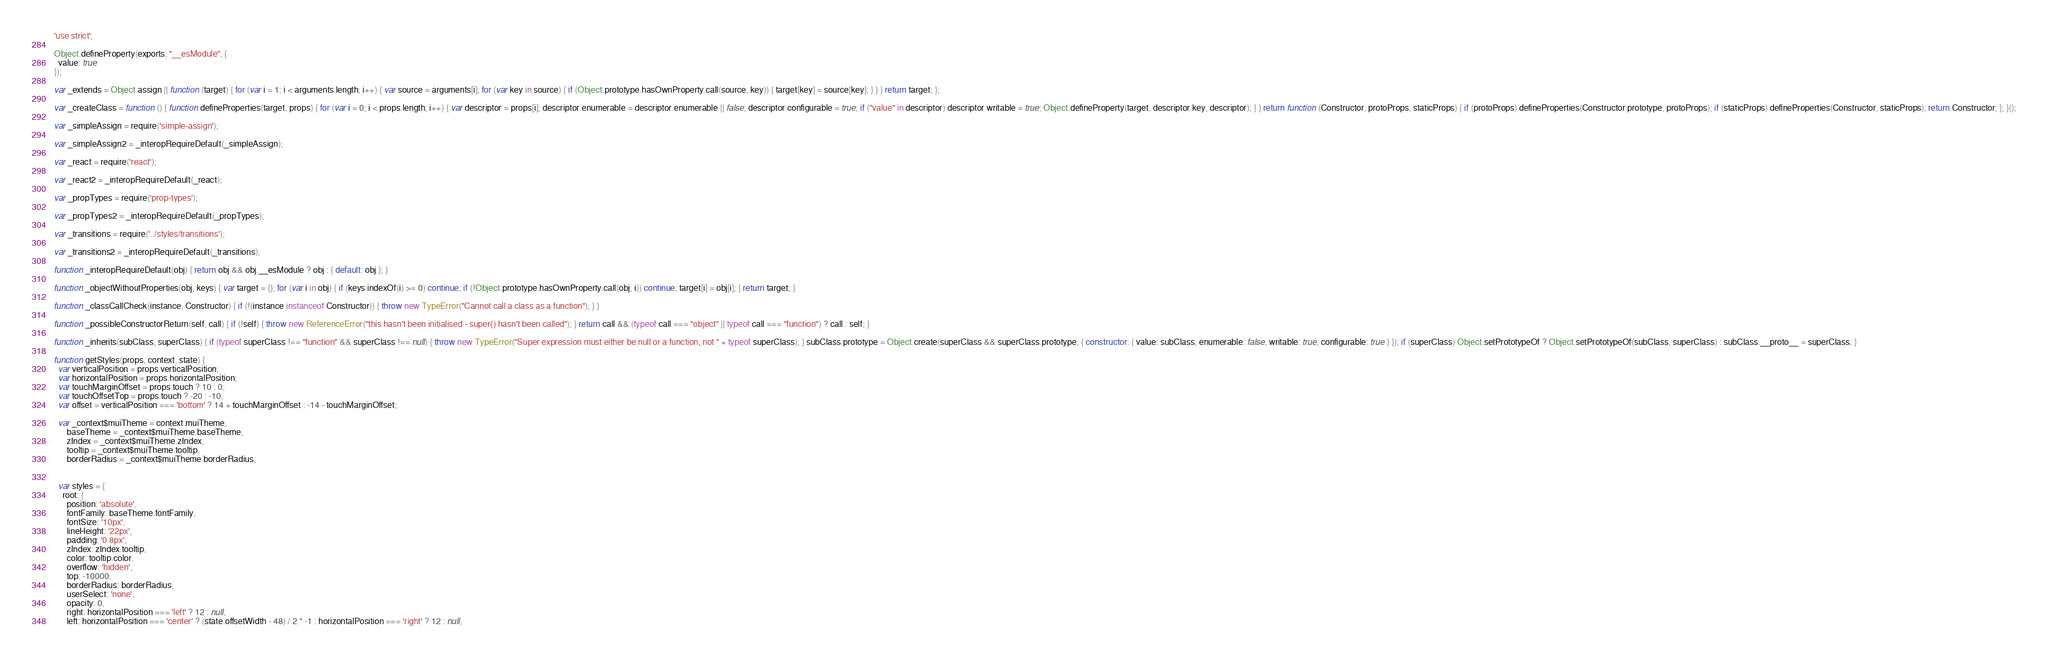Convert code to text. <code><loc_0><loc_0><loc_500><loc_500><_JavaScript_>'use strict';

Object.defineProperty(exports, "__esModule", {
  value: true
});

var _extends = Object.assign || function (target) { for (var i = 1; i < arguments.length; i++) { var source = arguments[i]; for (var key in source) { if (Object.prototype.hasOwnProperty.call(source, key)) { target[key] = source[key]; } } } return target; };

var _createClass = function () { function defineProperties(target, props) { for (var i = 0; i < props.length; i++) { var descriptor = props[i]; descriptor.enumerable = descriptor.enumerable || false; descriptor.configurable = true; if ("value" in descriptor) descriptor.writable = true; Object.defineProperty(target, descriptor.key, descriptor); } } return function (Constructor, protoProps, staticProps) { if (protoProps) defineProperties(Constructor.prototype, protoProps); if (staticProps) defineProperties(Constructor, staticProps); return Constructor; }; }();

var _simpleAssign = require('simple-assign');

var _simpleAssign2 = _interopRequireDefault(_simpleAssign);

var _react = require('react');

var _react2 = _interopRequireDefault(_react);

var _propTypes = require('prop-types');

var _propTypes2 = _interopRequireDefault(_propTypes);

var _transitions = require('../styles/transitions');

var _transitions2 = _interopRequireDefault(_transitions);

function _interopRequireDefault(obj) { return obj && obj.__esModule ? obj : { default: obj }; }

function _objectWithoutProperties(obj, keys) { var target = {}; for (var i in obj) { if (keys.indexOf(i) >= 0) continue; if (!Object.prototype.hasOwnProperty.call(obj, i)) continue; target[i] = obj[i]; } return target; }

function _classCallCheck(instance, Constructor) { if (!(instance instanceof Constructor)) { throw new TypeError("Cannot call a class as a function"); } }

function _possibleConstructorReturn(self, call) { if (!self) { throw new ReferenceError("this hasn't been initialised - super() hasn't been called"); } return call && (typeof call === "object" || typeof call === "function") ? call : self; }

function _inherits(subClass, superClass) { if (typeof superClass !== "function" && superClass !== null) { throw new TypeError("Super expression must either be null or a function, not " + typeof superClass); } subClass.prototype = Object.create(superClass && superClass.prototype, { constructor: { value: subClass, enumerable: false, writable: true, configurable: true } }); if (superClass) Object.setPrototypeOf ? Object.setPrototypeOf(subClass, superClass) : subClass.__proto__ = superClass; }

function getStyles(props, context, state) {
  var verticalPosition = props.verticalPosition;
  var horizontalPosition = props.horizontalPosition;
  var touchMarginOffset = props.touch ? 10 : 0;
  var touchOffsetTop = props.touch ? -20 : -10;
  var offset = verticalPosition === 'bottom' ? 14 + touchMarginOffset : -14 - touchMarginOffset;

  var _context$muiTheme = context.muiTheme,
      baseTheme = _context$muiTheme.baseTheme,
      zIndex = _context$muiTheme.zIndex,
      tooltip = _context$muiTheme.tooltip,
      borderRadius = _context$muiTheme.borderRadius;


  var styles = {
    root: {
      position: 'absolute',
      fontFamily: baseTheme.fontFamily,
      fontSize: '10px',
      lineHeight: '22px',
      padding: '0 8px',
      zIndex: zIndex.tooltip,
      color: tooltip.color,
      overflow: 'hidden',
      top: -10000,
      borderRadius: borderRadius,
      userSelect: 'none',
      opacity: 0,
      right: horizontalPosition === 'left' ? 12 : null,
      left: horizontalPosition === 'center' ? (state.offsetWidth - 48) / 2 * -1 : horizontalPosition === 'right' ? 12 : null,</code> 